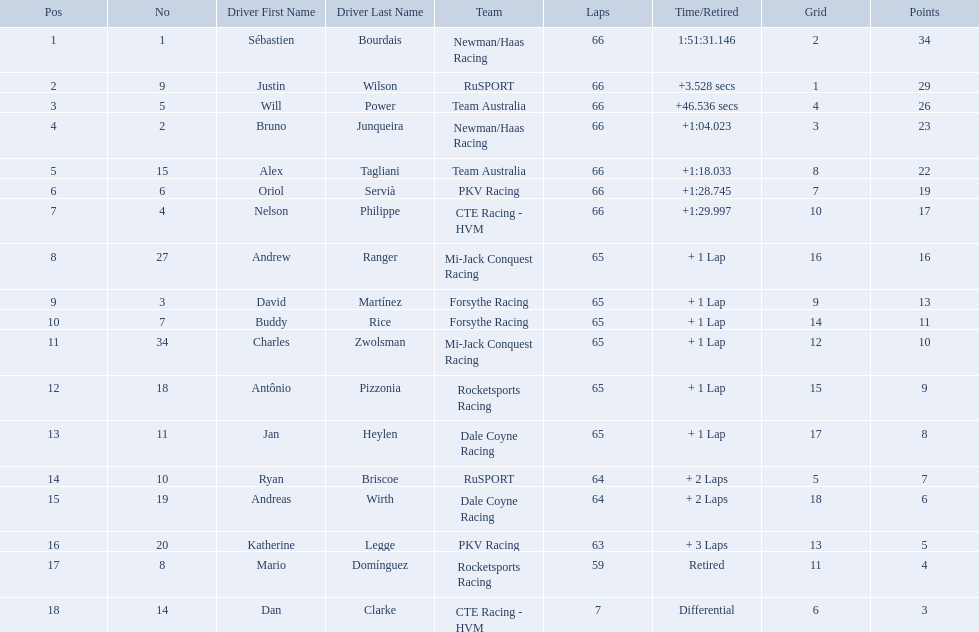How many points did first place receive? 34. How many did last place receive? 3. Who was the recipient of these last place points? Dan Clarke. Which teams participated in the 2006 gran premio telmex? Newman/Haas Racing, RuSPORT, Team Australia, Newman/Haas Racing, Team Australia, PKV Racing, CTE Racing - HVM, Mi-Jack Conquest Racing, Forsythe Racing, Forsythe Racing, Mi-Jack Conquest Racing, Rocketsports Racing, Dale Coyne Racing, RuSPORT, Dale Coyne Racing, PKV Racing, Rocketsports Racing, CTE Racing - HVM. Who were the drivers of these teams? Sébastien Bourdais, Justin Wilson, Will Power, Bruno Junqueira, Alex Tagliani, Oriol Servià, Nelson Philippe, Andrew Ranger, David Martínez, Buddy Rice, Charles Zwolsman, Antônio Pizzonia, Jan Heylen, Ryan Briscoe, Andreas Wirth, Katherine Legge, Mario Domínguez, Dan Clarke. Which driver finished last? Dan Clarke. Who are all of the 2006 gran premio telmex drivers? Sébastien Bourdais, Justin Wilson, Will Power, Bruno Junqueira, Alex Tagliani, Oriol Servià, Nelson Philippe, Andrew Ranger, David Martínez, Buddy Rice, Charles Zwolsman, Antônio Pizzonia, Jan Heylen, Ryan Briscoe, Andreas Wirth, Katherine Legge, Mario Domínguez, Dan Clarke. How many laps did they finish? 66, 66, 66, 66, 66, 66, 66, 65, 65, 65, 65, 65, 65, 64, 64, 63, 59, 7. What about just oriol servia and katherine legge? 66, 63. And which of those two drivers finished more laps? Oriol Servià. What was the highest amount of points scored in the 2006 gran premio? 34. Who scored 34 points? Sébastien Bourdais. Which drivers scored at least 10 points? Sébastien Bourdais, Justin Wilson, Will Power, Bruno Junqueira, Alex Tagliani, Oriol Servià, Nelson Philippe, Andrew Ranger, David Martínez, Buddy Rice, Charles Zwolsman. Of those drivers, which ones scored at least 20 points? Sébastien Bourdais, Justin Wilson, Will Power, Bruno Junqueira, Alex Tagliani. Of those 5, which driver scored the most points? Sébastien Bourdais. Can you give me this table as a dict? {'header': ['Pos', 'No', 'Driver First Name', 'Driver Last Name', 'Team', 'Laps', 'Time/Retired', 'Grid', 'Points'], 'rows': [['1', '1', 'Sébastien', 'Bourdais', 'Newman/Haas Racing', '66', '1:51:31.146', '2', '34'], ['2', '9', 'Justin', 'Wilson', 'RuSPORT', '66', '+3.528 secs', '1', '29'], ['3', '5', 'Will', 'Power', 'Team Australia', '66', '+46.536 secs', '4', '26'], ['4', '2', 'Bruno', 'Junqueira', 'Newman/Haas Racing', '66', '+1:04.023', '3', '23'], ['5', '15', 'Alex', 'Tagliani', 'Team Australia', '66', '+1:18.033', '8', '22'], ['6', '6', 'Oriol', 'Servià', 'PKV Racing', '66', '+1:28.745', '7', '19'], ['7', '4', 'Nelson', 'Philippe', 'CTE Racing - HVM', '66', '+1:29.997', '10', '17'], ['8', '27', 'Andrew', 'Ranger', 'Mi-Jack Conquest Racing', '65', '+ 1 Lap', '16', '16'], ['9', '3', 'David', 'Martínez', 'Forsythe Racing', '65', '+ 1 Lap', '9', '13'], ['10', '7', 'Buddy', 'Rice', 'Forsythe Racing', '65', '+ 1 Lap', '14', '11'], ['11', '34', 'Charles', 'Zwolsman', 'Mi-Jack Conquest Racing', '65', '+ 1 Lap', '12', '10'], ['12', '18', 'Antônio', 'Pizzonia', 'Rocketsports Racing', '65', '+ 1 Lap', '15', '9'], ['13', '11', 'Jan', 'Heylen', 'Dale Coyne Racing', '65', '+ 1 Lap', '17', '8'], ['14', '10', 'Ryan', 'Briscoe', 'RuSPORT', '64', '+ 2 Laps', '5', '7'], ['15', '19', 'Andreas', 'Wirth', 'Dale Coyne Racing', '64', '+ 2 Laps', '18', '6'], ['16', '20', 'Katherine', 'Legge', 'PKV Racing', '63', '+ 3 Laps', '13', '5'], ['17', '8', 'Mario', 'Domínguez', 'Rocketsports Racing', '59', 'Retired', '11', '4'], ['18', '14', 'Dan', 'Clarke', 'CTE Racing - HVM', '7', 'Differential', '6', '3']]} Which people scored 29+ points? Sébastien Bourdais, Justin Wilson. Who scored higher? Sébastien Bourdais. What are the drivers numbers? 1, 9, 5, 2, 15, 6, 4, 27, 3, 7, 34, 18, 11, 10, 19, 20, 8, 14. Are there any who's number matches his position? Sébastien Bourdais, Oriol Servià. Of those two who has the highest position? Sébastien Bourdais. 